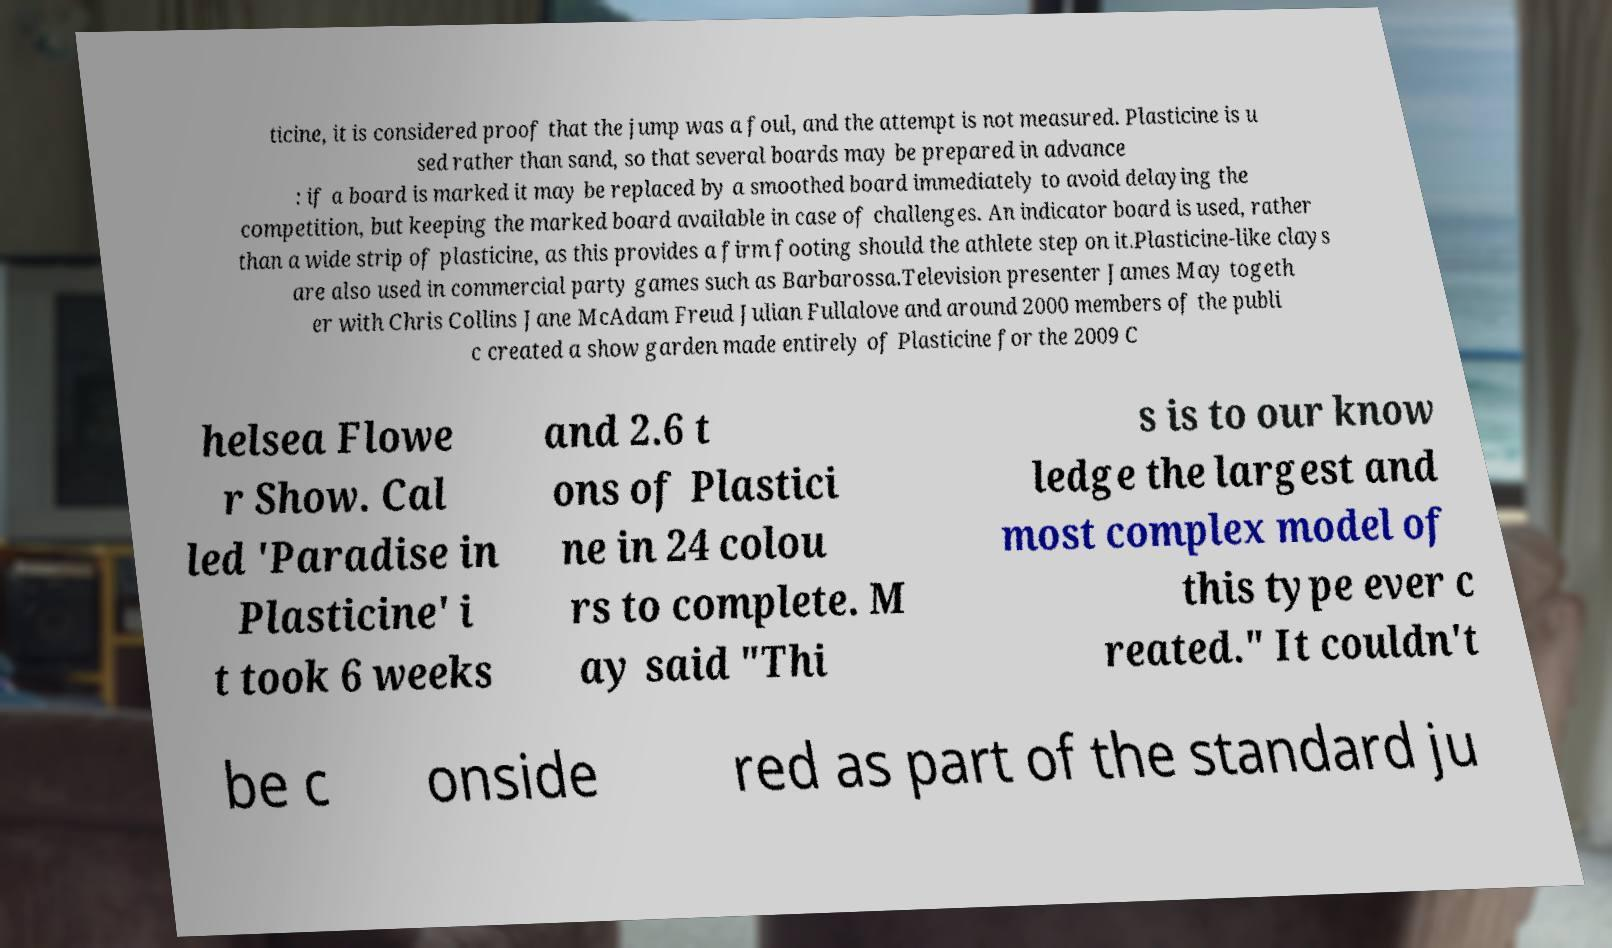What messages or text are displayed in this image? I need them in a readable, typed format. ticine, it is considered proof that the jump was a foul, and the attempt is not measured. Plasticine is u sed rather than sand, so that several boards may be prepared in advance : if a board is marked it may be replaced by a smoothed board immediately to avoid delaying the competition, but keeping the marked board available in case of challenges. An indicator board is used, rather than a wide strip of plasticine, as this provides a firm footing should the athlete step on it.Plasticine-like clays are also used in commercial party games such as Barbarossa.Television presenter James May togeth er with Chris Collins Jane McAdam Freud Julian Fullalove and around 2000 members of the publi c created a show garden made entirely of Plasticine for the 2009 C helsea Flowe r Show. Cal led 'Paradise in Plasticine' i t took 6 weeks and 2.6 t ons of Plastici ne in 24 colou rs to complete. M ay said "Thi s is to our know ledge the largest and most complex model of this type ever c reated." It couldn't be c onside red as part of the standard ju 